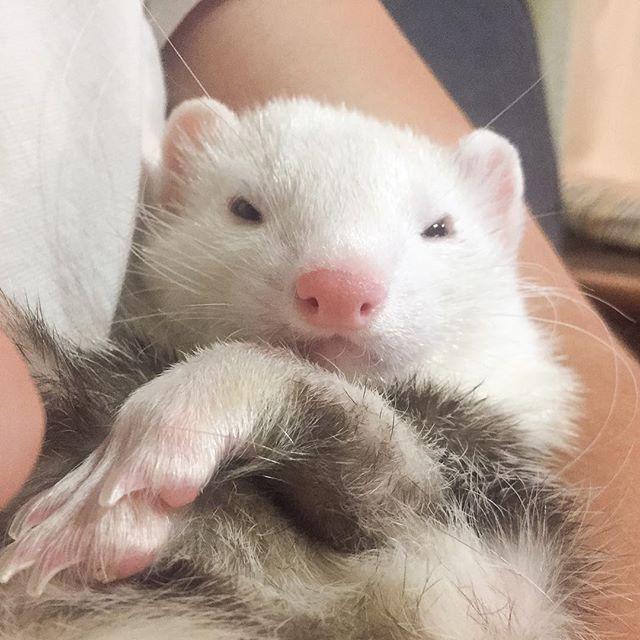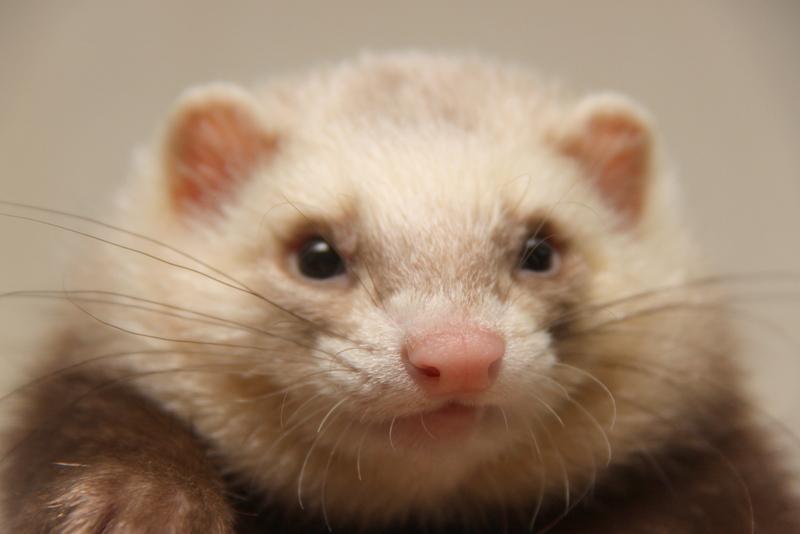The first image is the image on the left, the second image is the image on the right. Analyze the images presented: Is the assertion "One of the images shows an animal being held by a human." valid? Answer yes or no. Yes. The first image is the image on the left, the second image is the image on the right. Given the left and right images, does the statement "There is only one ferret in each of the images." hold true? Answer yes or no. Yes. 